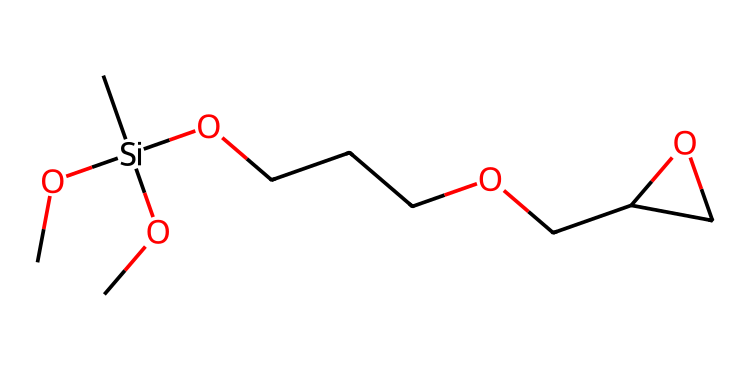What is the main functional group present in this silane? The SMILES structure indicates the presence of multiple alkoxy (-O-) groups and a hydroxyl (-OH) group, which are functional groups commonly found in silane coupling agents. The hydroxyl group specifically is the main functional group that can form bonds with silica surfaces.
Answer: hydroxyl How many carbon atoms are in this silane? By analyzing the SMILES notation, we can see that there are several "C" letters indicating carbon atoms. Counting them leads to a total of 10 carbon atoms in the structure.
Answer: ten What type of chemical is this silane classified as? This chemical contains silicon and is used to enhance adhesion in various applications, particularly in the context of adhesives for electronic assemblies. Given its properties, it can be classified as a silane coupling agent.
Answer: silane coupling agent How many oxygen atoms are present in this silane? The SMILES representation shows multiple occurrences of oxygen atoms, specifically associated with the -O- and -OH groups. Counting these in the structure reveals there are 5 oxygen atoms.
Answer: five What is the significance of the ether linkages in this silane? The ether linkages, indicated by the occurrence of -O- between carbon atoms, provide flexibility and ability to interact chemically with various substrates, enhancing adhesion and performance in adhesive applications.
Answer: enhanced adhesion What type of reaction can this silane undergo to bond with surfaces? The presence of hydroxyl groups allows this silane to undergo condensation reactions, forming siloxane bonds with hydroxylated surfaces, which is crucial for achieving strong adhesion in electronic device assembly.
Answer: condensation reaction How many silicon atoms are present in this silane? The SMILES notation shows a single "Si," indicating there is one silicon atom present in this silane structure.
Answer: one 